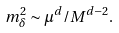Convert formula to latex. <formula><loc_0><loc_0><loc_500><loc_500>m ^ { 2 } _ { \delta } \sim \mu ^ { d } / M ^ { d - 2 } .</formula> 